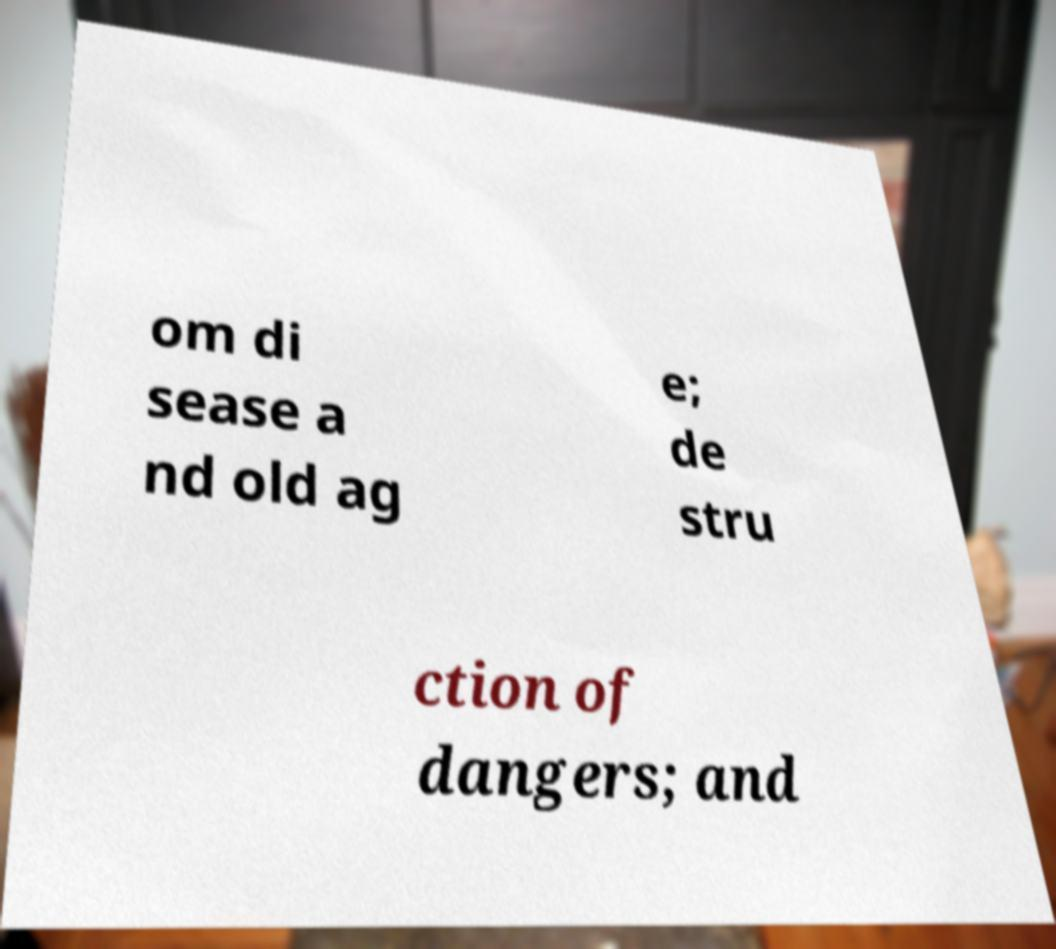Please read and relay the text visible in this image. What does it say? om di sease a nd old ag e; de stru ction of dangers; and 